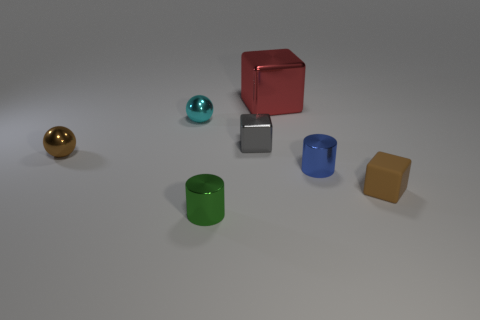Are there any small shiny spheres that have the same color as the small rubber block?
Provide a short and direct response. Yes. How many big things are brown balls or gray matte cylinders?
Make the answer very short. 0. Does the tiny cylinder that is on the right side of the green metal cylinder have the same material as the cyan sphere?
Provide a succinct answer. Yes. The large shiny object that is behind the metal cylinder that is to the right of the metallic block that is in front of the cyan metal object is what shape?
Your answer should be very brief. Cube. How many blue objects are small metal things or metallic balls?
Ensure brevity in your answer.  1. Are there the same number of small green metal cylinders right of the tiny blue metal thing and small things on the left side of the tiny gray object?
Ensure brevity in your answer.  No. Is the shape of the brown object left of the green thing the same as the small cyan object that is behind the small blue object?
Keep it short and to the point. Yes. The small gray thing that is made of the same material as the cyan thing is what shape?
Ensure brevity in your answer.  Cube. Are there the same number of cylinders that are behind the red block and big gray rubber objects?
Offer a very short reply. Yes. Are the block on the left side of the large red metallic object and the tiny brown object that is to the left of the big red thing made of the same material?
Give a very brief answer. Yes. 